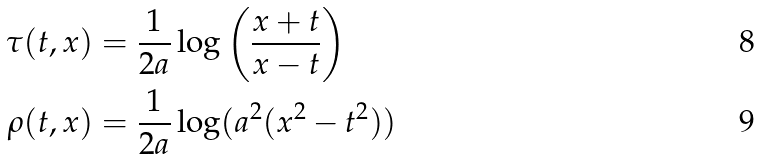Convert formula to latex. <formula><loc_0><loc_0><loc_500><loc_500>\tau ( t , x ) & = \frac { 1 } { 2 a } \log \left ( \frac { x + t } { x - t } \right ) \\ \rho ( t , x ) & = \frac { 1 } { 2 a } \log ( a ^ { 2 } ( x ^ { 2 } - t ^ { 2 } ) )</formula> 